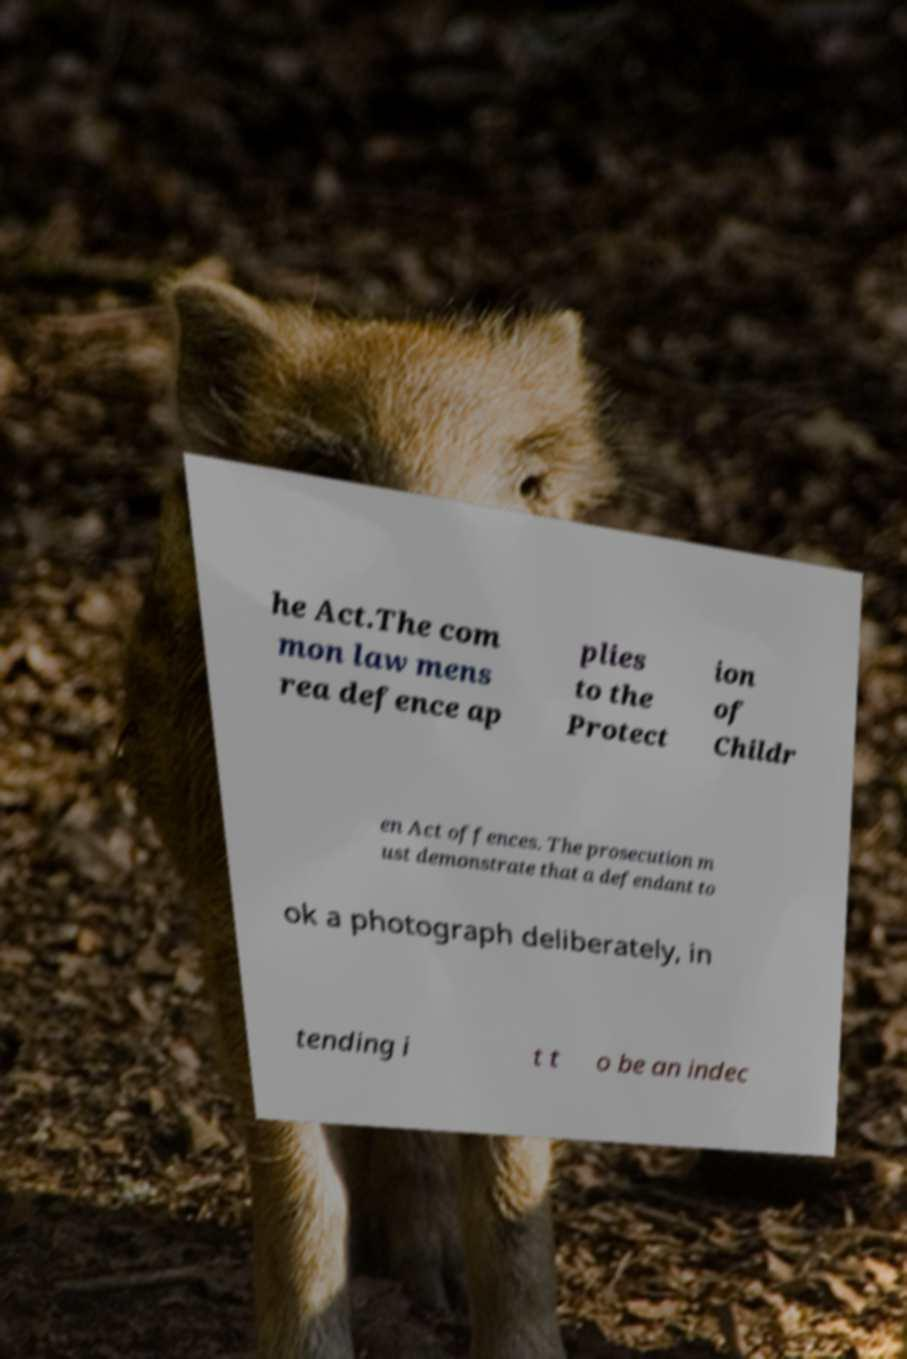For documentation purposes, I need the text within this image transcribed. Could you provide that? he Act.The com mon law mens rea defence ap plies to the Protect ion of Childr en Act offences. The prosecution m ust demonstrate that a defendant to ok a photograph deliberately, in tending i t t o be an indec 